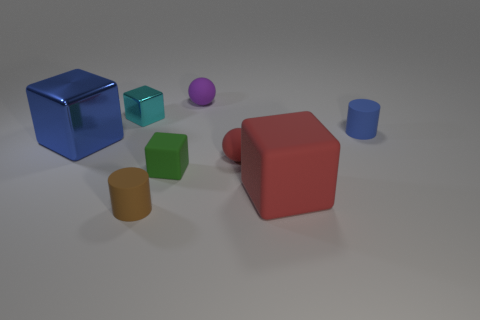Subtract all blue blocks. How many blocks are left? 3 Add 2 small gray matte objects. How many objects exist? 10 Subtract all blue blocks. How many blocks are left? 3 Subtract all balls. How many objects are left? 6 Subtract 3 blocks. How many blocks are left? 1 Subtract all blue balls. Subtract all purple cylinders. How many balls are left? 2 Subtract all yellow cylinders. How many purple spheres are left? 1 Subtract all tiny cyan rubber balls. Subtract all rubber balls. How many objects are left? 6 Add 1 small purple spheres. How many small purple spheres are left? 2 Add 6 big matte objects. How many big matte objects exist? 7 